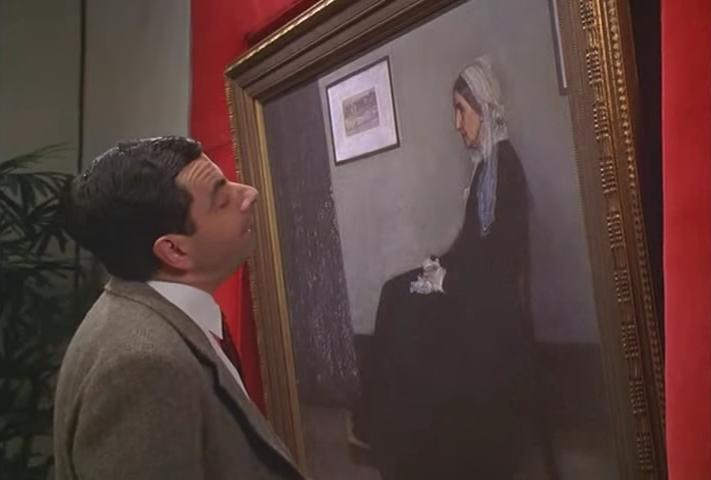Can you tell me more about the style of the painting he's looking at? Certainly. The painting appears to emulate the style of classical European portraiture. It uses a restricted, muted color palette, primarily composed of blues, grays, and the neutral tones of the woman's skin and headscarf. The brushwork seems deliberate and controlled, typical of traditional portraiture, which aims to meticulously capture the subject's appearance and mood. The woman's somber expression and the domestic setting can be commonly found in realistic genres of the 19th-century art. 